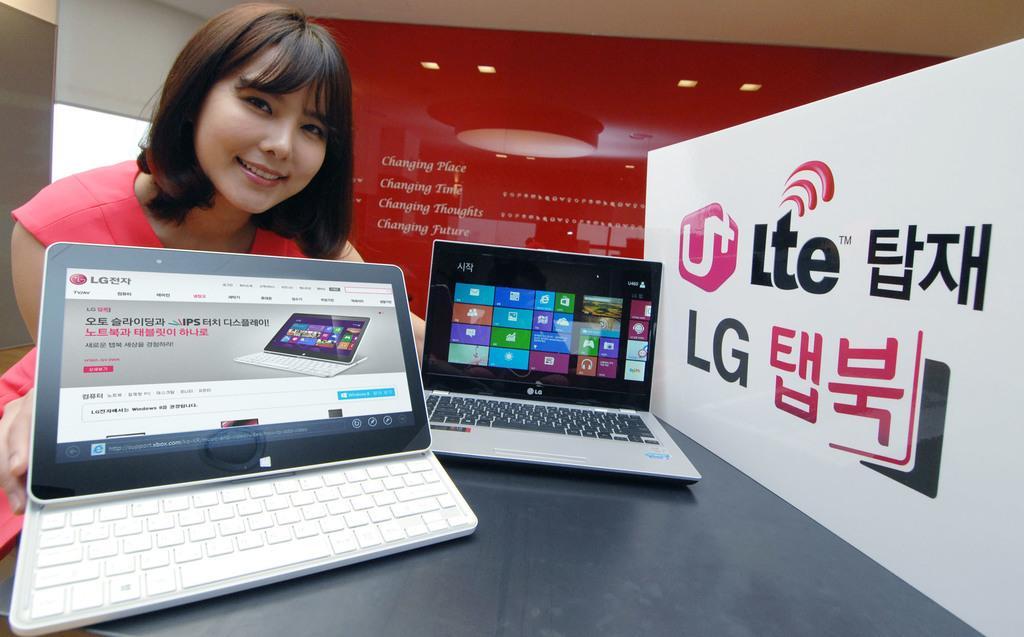Please provide a concise description of this image. In front of the image there is a table. On top of it there are two laptops. Beside the table there is a person having a smile on her face. On the right side of the image there is a board with some text on it. In the background of the image there is some text on the wall. On top of the image there are lights. On the left side of the image there is a glass window. 